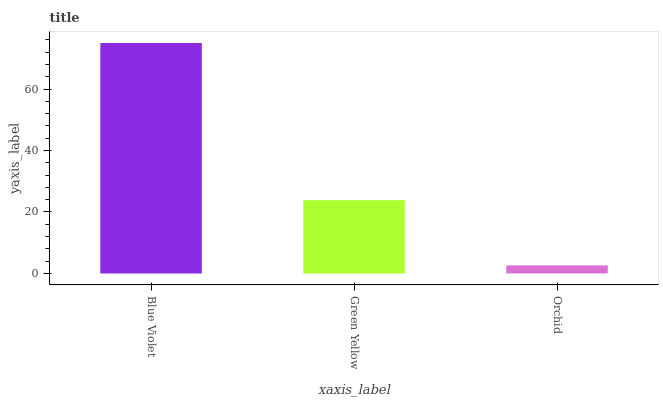Is Orchid the minimum?
Answer yes or no. Yes. Is Blue Violet the maximum?
Answer yes or no. Yes. Is Green Yellow the minimum?
Answer yes or no. No. Is Green Yellow the maximum?
Answer yes or no. No. Is Blue Violet greater than Green Yellow?
Answer yes or no. Yes. Is Green Yellow less than Blue Violet?
Answer yes or no. Yes. Is Green Yellow greater than Blue Violet?
Answer yes or no. No. Is Blue Violet less than Green Yellow?
Answer yes or no. No. Is Green Yellow the high median?
Answer yes or no. Yes. Is Green Yellow the low median?
Answer yes or no. Yes. Is Blue Violet the high median?
Answer yes or no. No. Is Blue Violet the low median?
Answer yes or no. No. 